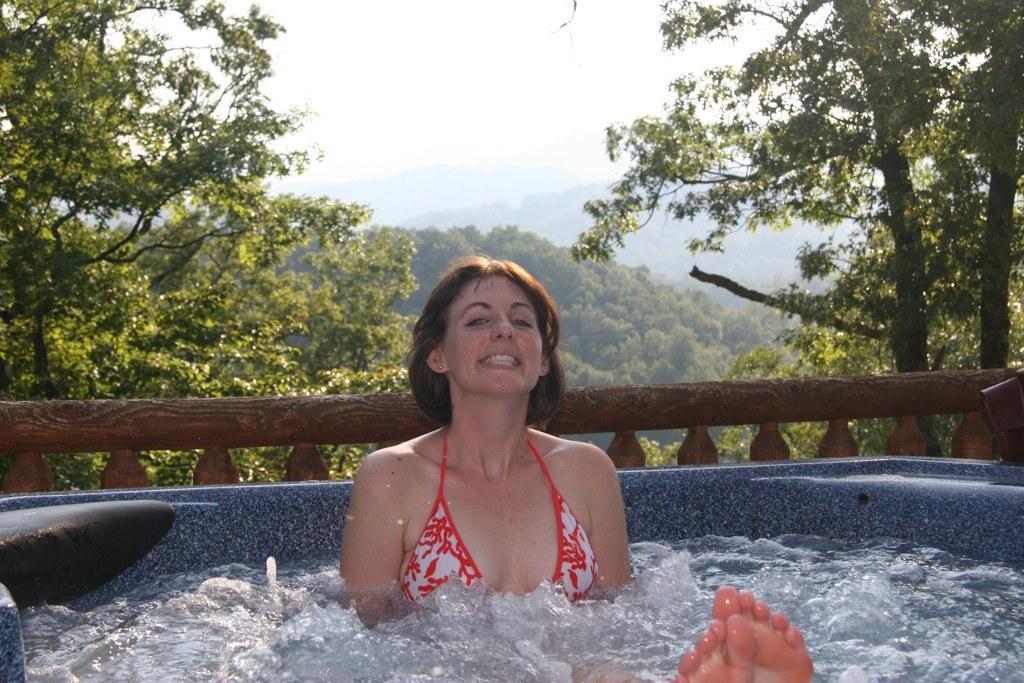In one or two sentences, can you explain what this image depicts? A woman is smiling. Here we can see water and fence. Background there are trees and sky. 